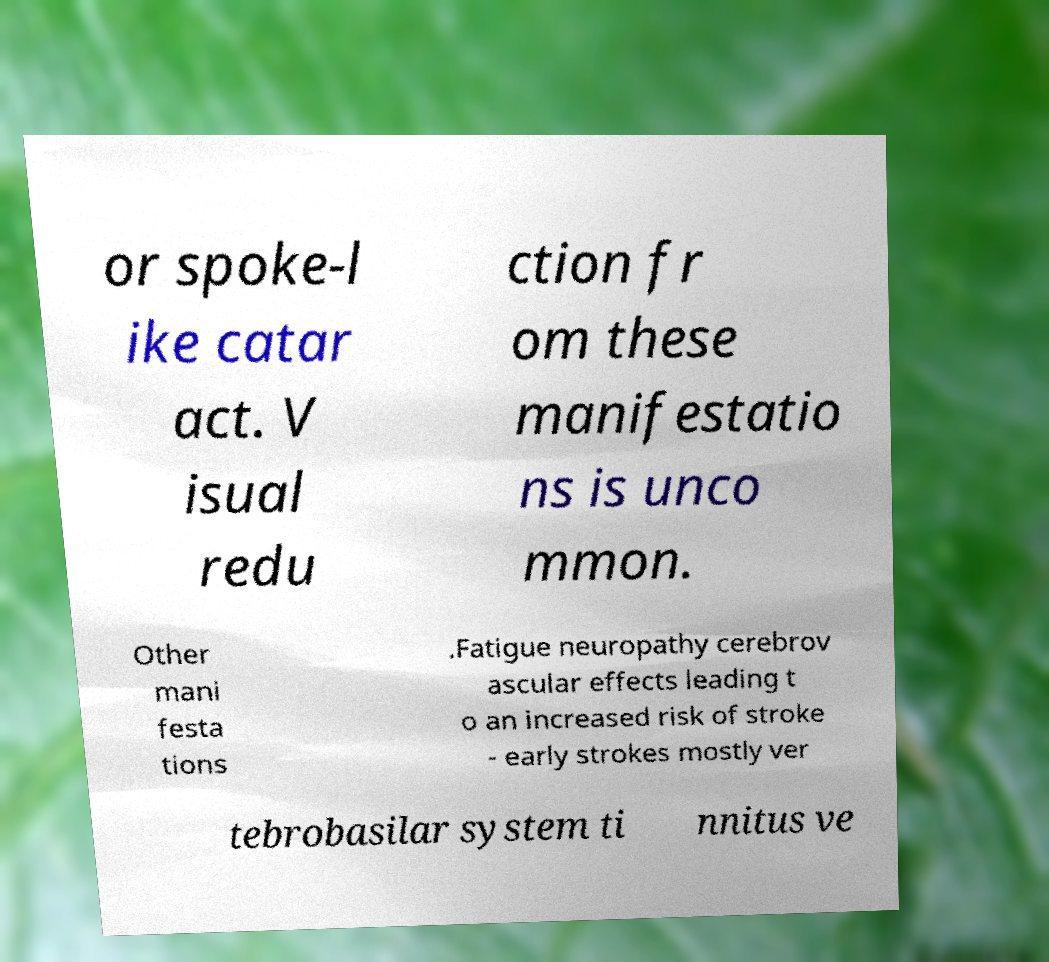Could you assist in decoding the text presented in this image and type it out clearly? or spoke-l ike catar act. V isual redu ction fr om these manifestatio ns is unco mmon. Other mani festa tions .Fatigue neuropathy cerebrov ascular effects leading t o an increased risk of stroke - early strokes mostly ver tebrobasilar system ti nnitus ve 